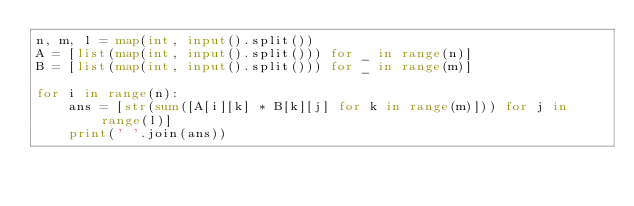<code> <loc_0><loc_0><loc_500><loc_500><_Python_>n, m, l = map(int, input().split())
A = [list(map(int, input().split())) for _ in range(n)]
B = [list(map(int, input().split())) for _ in range(m)]

for i in range(n):
    ans = [str(sum([A[i][k] * B[k][j] for k in range(m)])) for j in range(l)]
    print(' '.join(ans))

</code> 